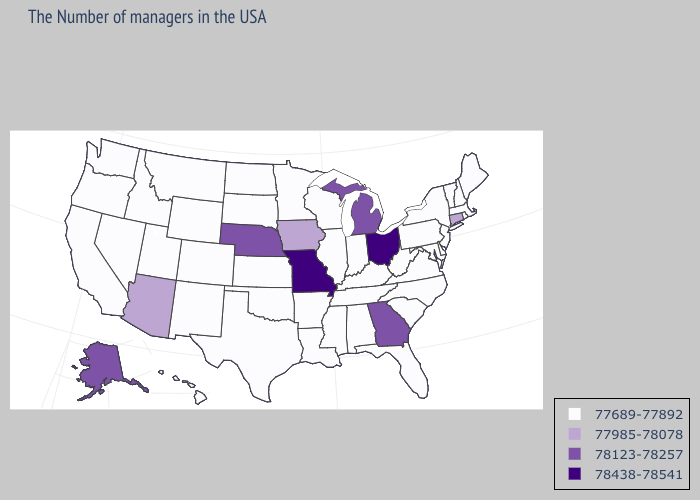What is the value of New Hampshire?
Answer briefly. 77689-77892. Name the states that have a value in the range 78123-78257?
Keep it brief. Georgia, Michigan, Nebraska, Alaska. What is the value of Wisconsin?
Be succinct. 77689-77892. Name the states that have a value in the range 78123-78257?
Be succinct. Georgia, Michigan, Nebraska, Alaska. What is the highest value in the USA?
Write a very short answer. 78438-78541. What is the highest value in states that border Texas?
Short answer required. 77689-77892. Does the first symbol in the legend represent the smallest category?
Short answer required. Yes. Does Mississippi have a lower value than Iowa?
Give a very brief answer. Yes. What is the lowest value in the USA?
Quick response, please. 77689-77892. Does Montana have the highest value in the West?
Quick response, please. No. Among the states that border Kentucky , does Missouri have the lowest value?
Concise answer only. No. What is the value of California?
Quick response, please. 77689-77892. Name the states that have a value in the range 78438-78541?
Short answer required. Ohio, Missouri. Among the states that border South Dakota , which have the lowest value?
Concise answer only. Minnesota, North Dakota, Wyoming, Montana. Does the first symbol in the legend represent the smallest category?
Concise answer only. Yes. 